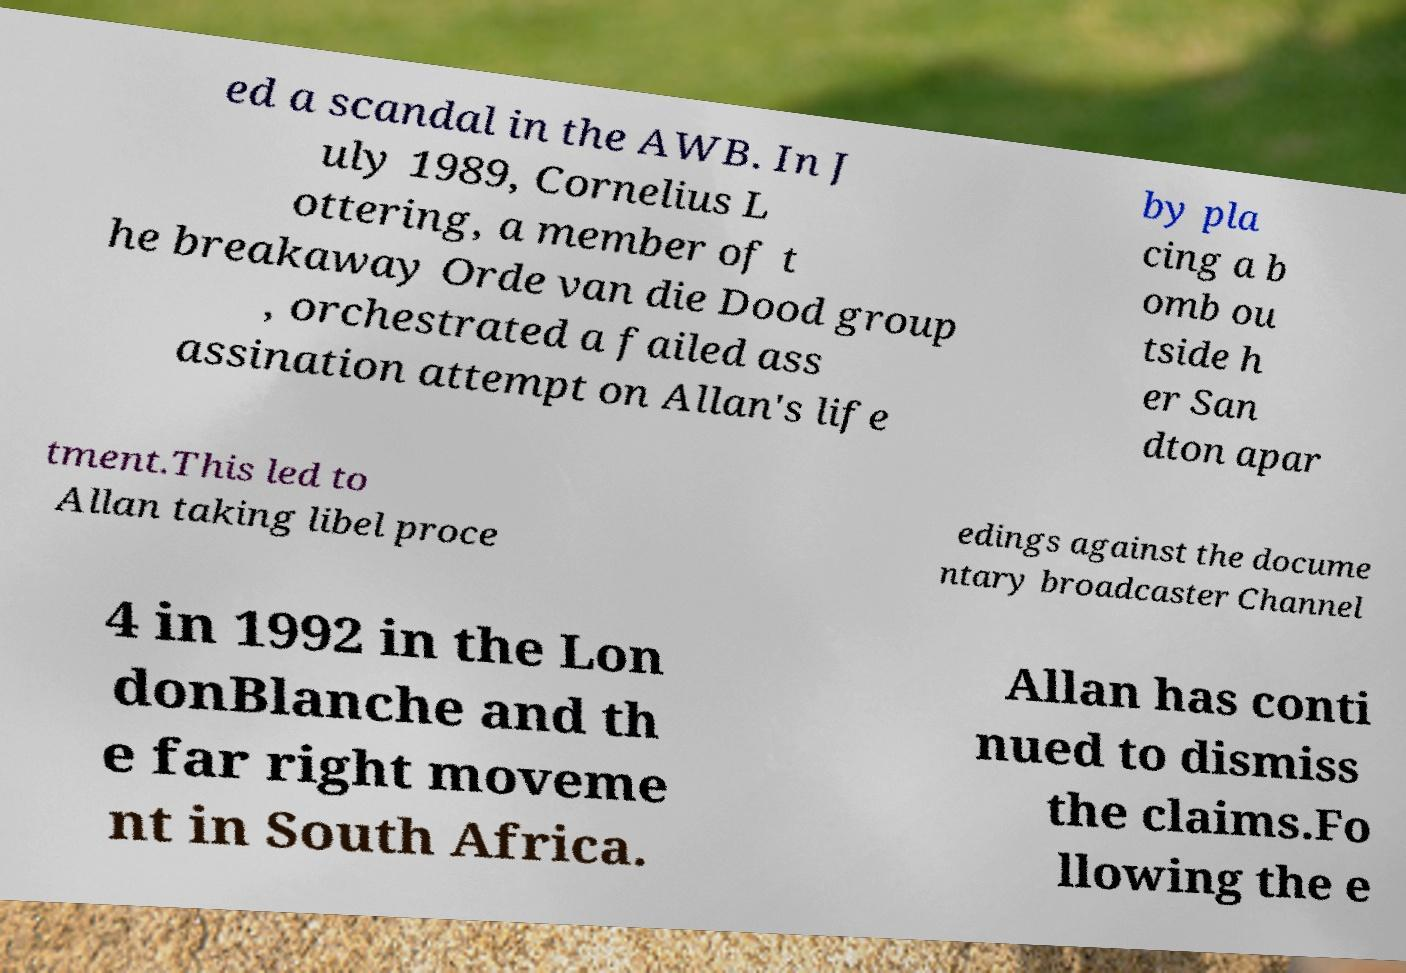Can you read and provide the text displayed in the image?This photo seems to have some interesting text. Can you extract and type it out for me? ed a scandal in the AWB. In J uly 1989, Cornelius L ottering, a member of t he breakaway Orde van die Dood group , orchestrated a failed ass assination attempt on Allan's life by pla cing a b omb ou tside h er San dton apar tment.This led to Allan taking libel proce edings against the docume ntary broadcaster Channel 4 in 1992 in the Lon donBlanche and th e far right moveme nt in South Africa. Allan has conti nued to dismiss the claims.Fo llowing the e 